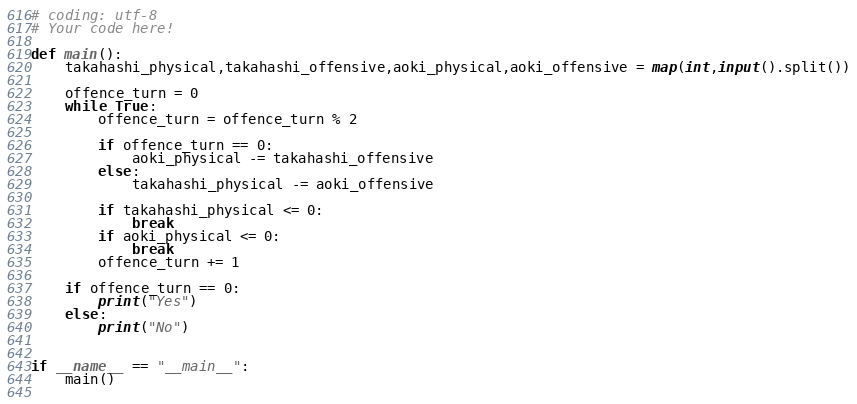<code> <loc_0><loc_0><loc_500><loc_500><_Python_># coding: utf-8
# Your code here!

def main():
    takahashi_physical,takahashi_offensive,aoki_physical,aoki_offensive = map(int,input().split())
    
    offence_turn = 0
    while True:
        offence_turn = offence_turn % 2
        
        if offence_turn == 0:
            aoki_physical -= takahashi_offensive
        else:
            takahashi_physical -= aoki_offensive
        
        if takahashi_physical <= 0:
            break
        if aoki_physical <= 0:
            break
        offence_turn += 1
        
    if offence_turn == 0:
        print("Yes")
    else:
        print("No")
    

if __name__ == "__main__":
    main()
    
</code> 